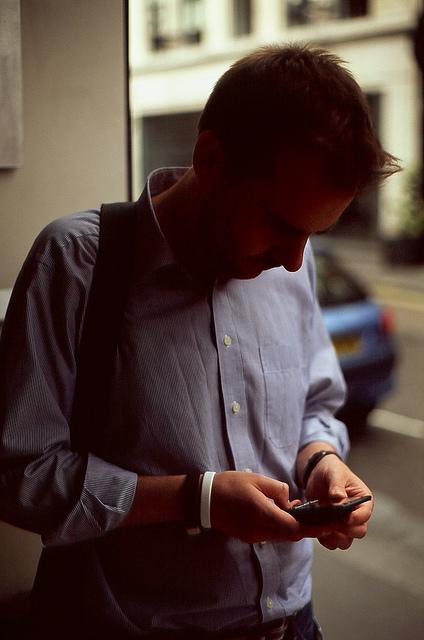Are they trying on a lighter?
Answer briefly. No. What is he wearing on his right wrist?
Short answer required. Bracelet. What color is the car?
Give a very brief answer. Blue. Is this person holding a smart device?
Give a very brief answer. Yes. 